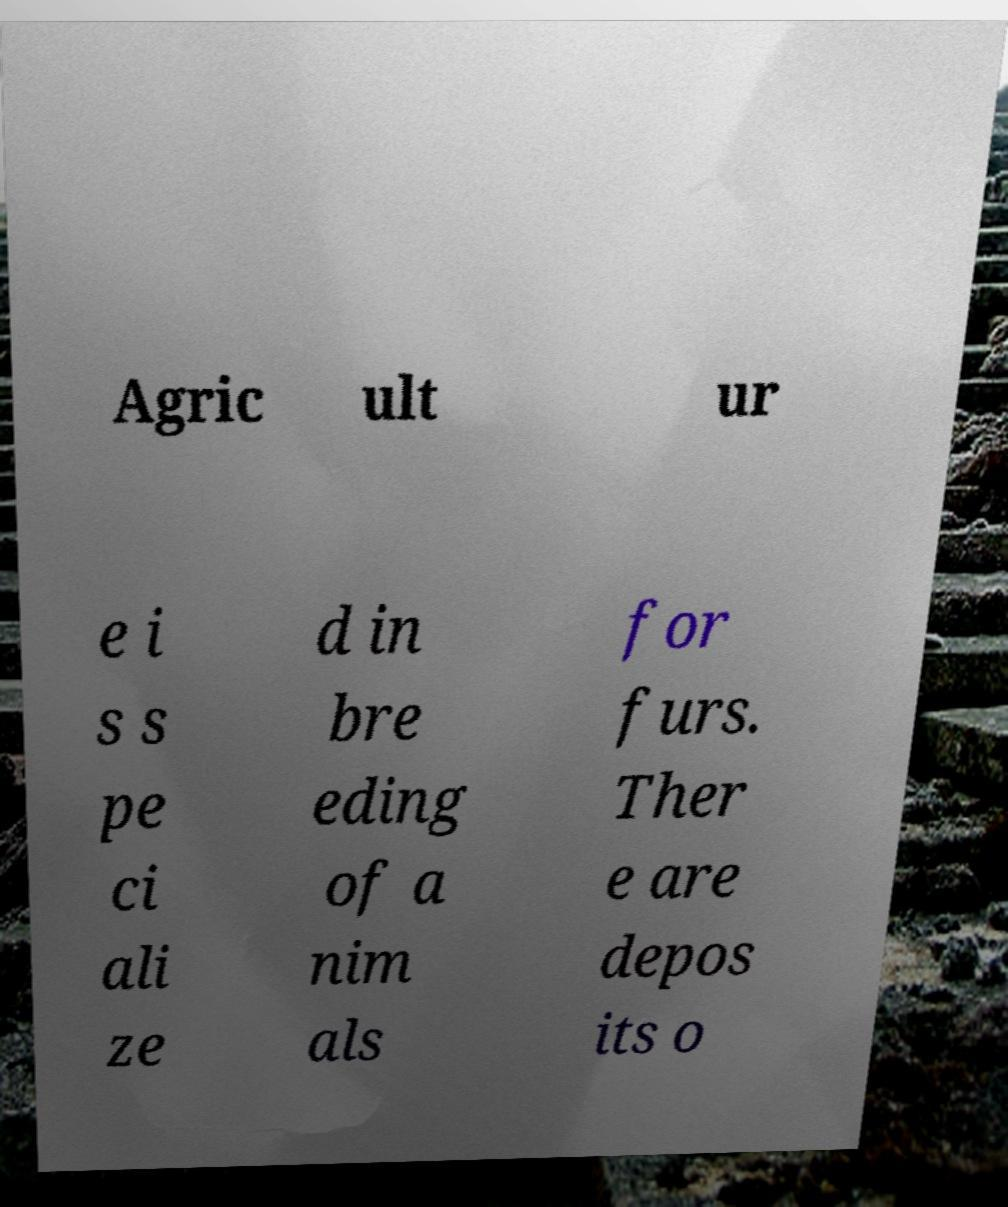Please identify and transcribe the text found in this image. Agric ult ur e i s s pe ci ali ze d in bre eding of a nim als for furs. Ther e are depos its o 